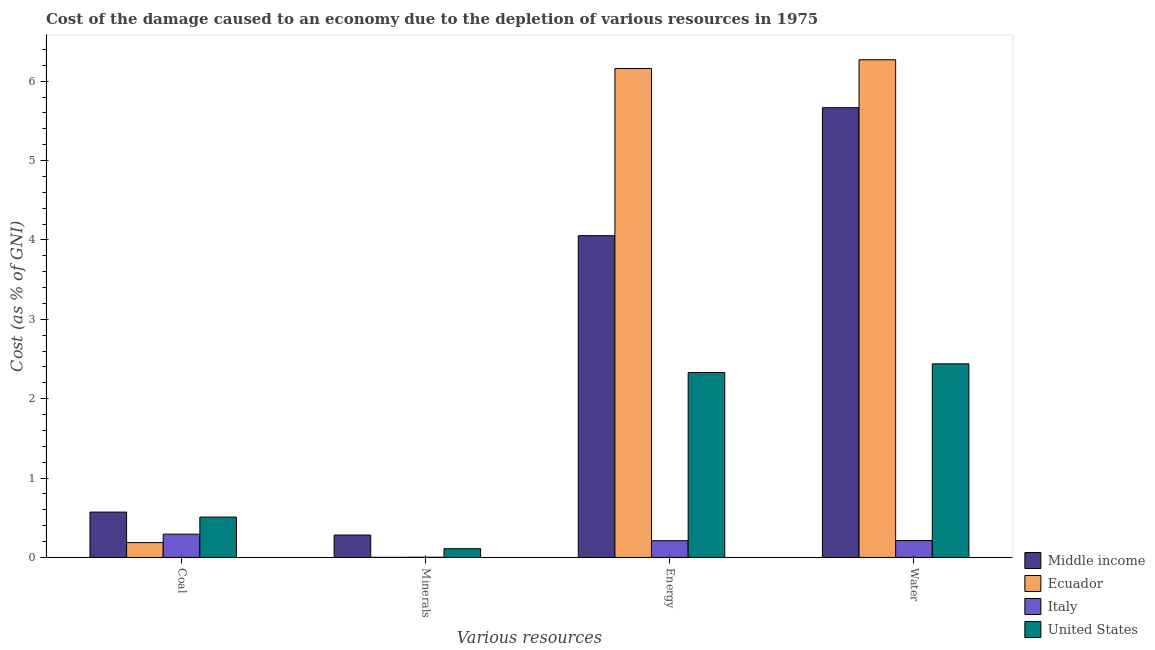How many different coloured bars are there?
Offer a terse response. 4. Are the number of bars on each tick of the X-axis equal?
Give a very brief answer. Yes. How many bars are there on the 1st tick from the left?
Provide a succinct answer. 4. How many bars are there on the 4th tick from the right?
Provide a short and direct response. 4. What is the label of the 4th group of bars from the left?
Your answer should be very brief. Water. What is the cost of damage due to depletion of coal in Ecuador?
Provide a short and direct response. 0.19. Across all countries, what is the maximum cost of damage due to depletion of water?
Your answer should be very brief. 6.27. Across all countries, what is the minimum cost of damage due to depletion of energy?
Your answer should be compact. 0.21. In which country was the cost of damage due to depletion of coal maximum?
Give a very brief answer. Middle income. In which country was the cost of damage due to depletion of coal minimum?
Your answer should be compact. Ecuador. What is the total cost of damage due to depletion of coal in the graph?
Make the answer very short. 1.56. What is the difference between the cost of damage due to depletion of minerals in Ecuador and that in United States?
Make the answer very short. -0.11. What is the difference between the cost of damage due to depletion of energy in Italy and the cost of damage due to depletion of minerals in United States?
Provide a short and direct response. 0.1. What is the average cost of damage due to depletion of coal per country?
Offer a very short reply. 0.39. What is the difference between the cost of damage due to depletion of energy and cost of damage due to depletion of water in Italy?
Offer a very short reply. -0. In how many countries, is the cost of damage due to depletion of coal greater than 6 %?
Your answer should be very brief. 0. What is the ratio of the cost of damage due to depletion of water in Italy to that in Ecuador?
Give a very brief answer. 0.03. Is the difference between the cost of damage due to depletion of energy in Middle income and Italy greater than the difference between the cost of damage due to depletion of minerals in Middle income and Italy?
Your answer should be compact. Yes. What is the difference between the highest and the second highest cost of damage due to depletion of minerals?
Your answer should be very brief. 0.17. What is the difference between the highest and the lowest cost of damage due to depletion of minerals?
Keep it short and to the point. 0.28. In how many countries, is the cost of damage due to depletion of water greater than the average cost of damage due to depletion of water taken over all countries?
Provide a short and direct response. 2. Is it the case that in every country, the sum of the cost of damage due to depletion of water and cost of damage due to depletion of minerals is greater than the sum of cost of damage due to depletion of coal and cost of damage due to depletion of energy?
Give a very brief answer. No. What does the 2nd bar from the right in Water represents?
Provide a short and direct response. Italy. Is it the case that in every country, the sum of the cost of damage due to depletion of coal and cost of damage due to depletion of minerals is greater than the cost of damage due to depletion of energy?
Your answer should be very brief. No. Are all the bars in the graph horizontal?
Your response must be concise. No. How many countries are there in the graph?
Provide a succinct answer. 4. Are the values on the major ticks of Y-axis written in scientific E-notation?
Provide a short and direct response. No. Does the graph contain grids?
Offer a terse response. No. How many legend labels are there?
Your answer should be very brief. 4. How are the legend labels stacked?
Your answer should be very brief. Vertical. What is the title of the graph?
Provide a succinct answer. Cost of the damage caused to an economy due to the depletion of various resources in 1975 . What is the label or title of the X-axis?
Your response must be concise. Various resources. What is the label or title of the Y-axis?
Provide a short and direct response. Cost (as % of GNI). What is the Cost (as % of GNI) of Middle income in Coal?
Make the answer very short. 0.57. What is the Cost (as % of GNI) in Ecuador in Coal?
Ensure brevity in your answer.  0.19. What is the Cost (as % of GNI) of Italy in Coal?
Make the answer very short. 0.29. What is the Cost (as % of GNI) of United States in Coal?
Offer a terse response. 0.51. What is the Cost (as % of GNI) of Middle income in Minerals?
Offer a terse response. 0.28. What is the Cost (as % of GNI) in Ecuador in Minerals?
Offer a very short reply. 0. What is the Cost (as % of GNI) in Italy in Minerals?
Keep it short and to the point. 0. What is the Cost (as % of GNI) in United States in Minerals?
Your response must be concise. 0.11. What is the Cost (as % of GNI) of Middle income in Energy?
Give a very brief answer. 4.05. What is the Cost (as % of GNI) in Ecuador in Energy?
Make the answer very short. 6.16. What is the Cost (as % of GNI) in Italy in Energy?
Provide a short and direct response. 0.21. What is the Cost (as % of GNI) in United States in Energy?
Offer a terse response. 2.33. What is the Cost (as % of GNI) in Middle income in Water?
Your answer should be very brief. 5.67. What is the Cost (as % of GNI) in Ecuador in Water?
Make the answer very short. 6.27. What is the Cost (as % of GNI) of Italy in Water?
Keep it short and to the point. 0.21. What is the Cost (as % of GNI) of United States in Water?
Your response must be concise. 2.44. Across all Various resources, what is the maximum Cost (as % of GNI) in Middle income?
Offer a very short reply. 5.67. Across all Various resources, what is the maximum Cost (as % of GNI) of Ecuador?
Your answer should be compact. 6.27. Across all Various resources, what is the maximum Cost (as % of GNI) of Italy?
Your answer should be compact. 0.29. Across all Various resources, what is the maximum Cost (as % of GNI) of United States?
Offer a very short reply. 2.44. Across all Various resources, what is the minimum Cost (as % of GNI) in Middle income?
Offer a very short reply. 0.28. Across all Various resources, what is the minimum Cost (as % of GNI) in Ecuador?
Keep it short and to the point. 0. Across all Various resources, what is the minimum Cost (as % of GNI) of Italy?
Provide a succinct answer. 0. Across all Various resources, what is the minimum Cost (as % of GNI) in United States?
Offer a terse response. 0.11. What is the total Cost (as % of GNI) in Middle income in the graph?
Ensure brevity in your answer.  10.57. What is the total Cost (as % of GNI) of Ecuador in the graph?
Give a very brief answer. 12.62. What is the total Cost (as % of GNI) in Italy in the graph?
Provide a succinct answer. 0.72. What is the total Cost (as % of GNI) in United States in the graph?
Ensure brevity in your answer.  5.39. What is the difference between the Cost (as % of GNI) in Middle income in Coal and that in Minerals?
Provide a short and direct response. 0.29. What is the difference between the Cost (as % of GNI) of Ecuador in Coal and that in Minerals?
Offer a terse response. 0.19. What is the difference between the Cost (as % of GNI) of Italy in Coal and that in Minerals?
Keep it short and to the point. 0.29. What is the difference between the Cost (as % of GNI) of United States in Coal and that in Minerals?
Provide a short and direct response. 0.4. What is the difference between the Cost (as % of GNI) in Middle income in Coal and that in Energy?
Your response must be concise. -3.48. What is the difference between the Cost (as % of GNI) in Ecuador in Coal and that in Energy?
Provide a short and direct response. -5.97. What is the difference between the Cost (as % of GNI) of Italy in Coal and that in Energy?
Provide a succinct answer. 0.08. What is the difference between the Cost (as % of GNI) in United States in Coal and that in Energy?
Provide a succinct answer. -1.82. What is the difference between the Cost (as % of GNI) of Middle income in Coal and that in Water?
Offer a terse response. -5.1. What is the difference between the Cost (as % of GNI) of Ecuador in Coal and that in Water?
Keep it short and to the point. -6.08. What is the difference between the Cost (as % of GNI) in Italy in Coal and that in Water?
Your answer should be very brief. 0.08. What is the difference between the Cost (as % of GNI) of United States in Coal and that in Water?
Provide a short and direct response. -1.93. What is the difference between the Cost (as % of GNI) in Middle income in Minerals and that in Energy?
Your response must be concise. -3.77. What is the difference between the Cost (as % of GNI) in Ecuador in Minerals and that in Energy?
Your answer should be compact. -6.16. What is the difference between the Cost (as % of GNI) in Italy in Minerals and that in Energy?
Your response must be concise. -0.21. What is the difference between the Cost (as % of GNI) in United States in Minerals and that in Energy?
Provide a short and direct response. -2.22. What is the difference between the Cost (as % of GNI) in Middle income in Minerals and that in Water?
Give a very brief answer. -5.38. What is the difference between the Cost (as % of GNI) of Ecuador in Minerals and that in Water?
Give a very brief answer. -6.27. What is the difference between the Cost (as % of GNI) in Italy in Minerals and that in Water?
Your response must be concise. -0.21. What is the difference between the Cost (as % of GNI) in United States in Minerals and that in Water?
Give a very brief answer. -2.33. What is the difference between the Cost (as % of GNI) in Middle income in Energy and that in Water?
Offer a very short reply. -1.61. What is the difference between the Cost (as % of GNI) of Ecuador in Energy and that in Water?
Your answer should be compact. -0.11. What is the difference between the Cost (as % of GNI) of Italy in Energy and that in Water?
Give a very brief answer. -0. What is the difference between the Cost (as % of GNI) in United States in Energy and that in Water?
Give a very brief answer. -0.11. What is the difference between the Cost (as % of GNI) in Middle income in Coal and the Cost (as % of GNI) in Ecuador in Minerals?
Ensure brevity in your answer.  0.57. What is the difference between the Cost (as % of GNI) in Middle income in Coal and the Cost (as % of GNI) in Italy in Minerals?
Keep it short and to the point. 0.57. What is the difference between the Cost (as % of GNI) of Middle income in Coal and the Cost (as % of GNI) of United States in Minerals?
Give a very brief answer. 0.46. What is the difference between the Cost (as % of GNI) of Ecuador in Coal and the Cost (as % of GNI) of Italy in Minerals?
Provide a short and direct response. 0.18. What is the difference between the Cost (as % of GNI) of Ecuador in Coal and the Cost (as % of GNI) of United States in Minerals?
Offer a very short reply. 0.08. What is the difference between the Cost (as % of GNI) in Italy in Coal and the Cost (as % of GNI) in United States in Minerals?
Give a very brief answer. 0.18. What is the difference between the Cost (as % of GNI) of Middle income in Coal and the Cost (as % of GNI) of Ecuador in Energy?
Your response must be concise. -5.59. What is the difference between the Cost (as % of GNI) of Middle income in Coal and the Cost (as % of GNI) of Italy in Energy?
Keep it short and to the point. 0.36. What is the difference between the Cost (as % of GNI) in Middle income in Coal and the Cost (as % of GNI) in United States in Energy?
Make the answer very short. -1.76. What is the difference between the Cost (as % of GNI) of Ecuador in Coal and the Cost (as % of GNI) of Italy in Energy?
Provide a short and direct response. -0.02. What is the difference between the Cost (as % of GNI) of Ecuador in Coal and the Cost (as % of GNI) of United States in Energy?
Provide a short and direct response. -2.14. What is the difference between the Cost (as % of GNI) in Italy in Coal and the Cost (as % of GNI) in United States in Energy?
Provide a succinct answer. -2.04. What is the difference between the Cost (as % of GNI) in Middle income in Coal and the Cost (as % of GNI) in Ecuador in Water?
Provide a succinct answer. -5.7. What is the difference between the Cost (as % of GNI) in Middle income in Coal and the Cost (as % of GNI) in Italy in Water?
Offer a terse response. 0.36. What is the difference between the Cost (as % of GNI) of Middle income in Coal and the Cost (as % of GNI) of United States in Water?
Your response must be concise. -1.87. What is the difference between the Cost (as % of GNI) in Ecuador in Coal and the Cost (as % of GNI) in Italy in Water?
Your answer should be very brief. -0.03. What is the difference between the Cost (as % of GNI) of Ecuador in Coal and the Cost (as % of GNI) of United States in Water?
Provide a short and direct response. -2.25. What is the difference between the Cost (as % of GNI) of Italy in Coal and the Cost (as % of GNI) of United States in Water?
Your answer should be very brief. -2.15. What is the difference between the Cost (as % of GNI) of Middle income in Minerals and the Cost (as % of GNI) of Ecuador in Energy?
Offer a terse response. -5.88. What is the difference between the Cost (as % of GNI) in Middle income in Minerals and the Cost (as % of GNI) in Italy in Energy?
Your response must be concise. 0.07. What is the difference between the Cost (as % of GNI) in Middle income in Minerals and the Cost (as % of GNI) in United States in Energy?
Offer a terse response. -2.05. What is the difference between the Cost (as % of GNI) in Ecuador in Minerals and the Cost (as % of GNI) in Italy in Energy?
Your answer should be very brief. -0.21. What is the difference between the Cost (as % of GNI) of Ecuador in Minerals and the Cost (as % of GNI) of United States in Energy?
Offer a terse response. -2.33. What is the difference between the Cost (as % of GNI) in Italy in Minerals and the Cost (as % of GNI) in United States in Energy?
Your answer should be compact. -2.33. What is the difference between the Cost (as % of GNI) of Middle income in Minerals and the Cost (as % of GNI) of Ecuador in Water?
Your answer should be very brief. -5.99. What is the difference between the Cost (as % of GNI) in Middle income in Minerals and the Cost (as % of GNI) in Italy in Water?
Provide a short and direct response. 0.07. What is the difference between the Cost (as % of GNI) in Middle income in Minerals and the Cost (as % of GNI) in United States in Water?
Your answer should be very brief. -2.16. What is the difference between the Cost (as % of GNI) in Ecuador in Minerals and the Cost (as % of GNI) in Italy in Water?
Offer a terse response. -0.21. What is the difference between the Cost (as % of GNI) in Ecuador in Minerals and the Cost (as % of GNI) in United States in Water?
Offer a terse response. -2.44. What is the difference between the Cost (as % of GNI) of Italy in Minerals and the Cost (as % of GNI) of United States in Water?
Your answer should be very brief. -2.44. What is the difference between the Cost (as % of GNI) of Middle income in Energy and the Cost (as % of GNI) of Ecuador in Water?
Provide a succinct answer. -2.22. What is the difference between the Cost (as % of GNI) of Middle income in Energy and the Cost (as % of GNI) of Italy in Water?
Provide a succinct answer. 3.84. What is the difference between the Cost (as % of GNI) in Middle income in Energy and the Cost (as % of GNI) in United States in Water?
Give a very brief answer. 1.61. What is the difference between the Cost (as % of GNI) of Ecuador in Energy and the Cost (as % of GNI) of Italy in Water?
Your answer should be compact. 5.95. What is the difference between the Cost (as % of GNI) in Ecuador in Energy and the Cost (as % of GNI) in United States in Water?
Ensure brevity in your answer.  3.72. What is the difference between the Cost (as % of GNI) in Italy in Energy and the Cost (as % of GNI) in United States in Water?
Provide a short and direct response. -2.23. What is the average Cost (as % of GNI) in Middle income per Various resources?
Provide a short and direct response. 2.64. What is the average Cost (as % of GNI) of Ecuador per Various resources?
Your answer should be compact. 3.15. What is the average Cost (as % of GNI) of Italy per Various resources?
Offer a terse response. 0.18. What is the average Cost (as % of GNI) of United States per Various resources?
Keep it short and to the point. 1.35. What is the difference between the Cost (as % of GNI) of Middle income and Cost (as % of GNI) of Ecuador in Coal?
Ensure brevity in your answer.  0.38. What is the difference between the Cost (as % of GNI) of Middle income and Cost (as % of GNI) of Italy in Coal?
Offer a very short reply. 0.28. What is the difference between the Cost (as % of GNI) of Middle income and Cost (as % of GNI) of United States in Coal?
Keep it short and to the point. 0.06. What is the difference between the Cost (as % of GNI) of Ecuador and Cost (as % of GNI) of Italy in Coal?
Keep it short and to the point. -0.11. What is the difference between the Cost (as % of GNI) in Ecuador and Cost (as % of GNI) in United States in Coal?
Your response must be concise. -0.32. What is the difference between the Cost (as % of GNI) of Italy and Cost (as % of GNI) of United States in Coal?
Offer a terse response. -0.22. What is the difference between the Cost (as % of GNI) of Middle income and Cost (as % of GNI) of Ecuador in Minerals?
Ensure brevity in your answer.  0.28. What is the difference between the Cost (as % of GNI) of Middle income and Cost (as % of GNI) of Italy in Minerals?
Your response must be concise. 0.28. What is the difference between the Cost (as % of GNI) in Middle income and Cost (as % of GNI) in United States in Minerals?
Keep it short and to the point. 0.17. What is the difference between the Cost (as % of GNI) of Ecuador and Cost (as % of GNI) of Italy in Minerals?
Your response must be concise. -0. What is the difference between the Cost (as % of GNI) of Ecuador and Cost (as % of GNI) of United States in Minerals?
Offer a very short reply. -0.11. What is the difference between the Cost (as % of GNI) of Italy and Cost (as % of GNI) of United States in Minerals?
Ensure brevity in your answer.  -0.11. What is the difference between the Cost (as % of GNI) of Middle income and Cost (as % of GNI) of Ecuador in Energy?
Make the answer very short. -2.11. What is the difference between the Cost (as % of GNI) of Middle income and Cost (as % of GNI) of Italy in Energy?
Your response must be concise. 3.84. What is the difference between the Cost (as % of GNI) in Middle income and Cost (as % of GNI) in United States in Energy?
Ensure brevity in your answer.  1.72. What is the difference between the Cost (as % of GNI) in Ecuador and Cost (as % of GNI) in Italy in Energy?
Offer a very short reply. 5.95. What is the difference between the Cost (as % of GNI) in Ecuador and Cost (as % of GNI) in United States in Energy?
Give a very brief answer. 3.83. What is the difference between the Cost (as % of GNI) in Italy and Cost (as % of GNI) in United States in Energy?
Provide a short and direct response. -2.12. What is the difference between the Cost (as % of GNI) in Middle income and Cost (as % of GNI) in Ecuador in Water?
Give a very brief answer. -0.6. What is the difference between the Cost (as % of GNI) of Middle income and Cost (as % of GNI) of Italy in Water?
Keep it short and to the point. 5.45. What is the difference between the Cost (as % of GNI) of Middle income and Cost (as % of GNI) of United States in Water?
Your answer should be very brief. 3.23. What is the difference between the Cost (as % of GNI) in Ecuador and Cost (as % of GNI) in Italy in Water?
Provide a short and direct response. 6.06. What is the difference between the Cost (as % of GNI) of Ecuador and Cost (as % of GNI) of United States in Water?
Provide a short and direct response. 3.83. What is the difference between the Cost (as % of GNI) in Italy and Cost (as % of GNI) in United States in Water?
Give a very brief answer. -2.23. What is the ratio of the Cost (as % of GNI) of Middle income in Coal to that in Minerals?
Make the answer very short. 2.03. What is the ratio of the Cost (as % of GNI) of Ecuador in Coal to that in Minerals?
Give a very brief answer. 352.48. What is the ratio of the Cost (as % of GNI) of Italy in Coal to that in Minerals?
Offer a terse response. 136.52. What is the ratio of the Cost (as % of GNI) of United States in Coal to that in Minerals?
Your answer should be very brief. 4.63. What is the ratio of the Cost (as % of GNI) in Middle income in Coal to that in Energy?
Keep it short and to the point. 0.14. What is the ratio of the Cost (as % of GNI) of Ecuador in Coal to that in Energy?
Make the answer very short. 0.03. What is the ratio of the Cost (as % of GNI) in Italy in Coal to that in Energy?
Provide a succinct answer. 1.39. What is the ratio of the Cost (as % of GNI) of United States in Coal to that in Energy?
Your answer should be compact. 0.22. What is the ratio of the Cost (as % of GNI) of Middle income in Coal to that in Water?
Ensure brevity in your answer.  0.1. What is the ratio of the Cost (as % of GNI) of Ecuador in Coal to that in Water?
Keep it short and to the point. 0.03. What is the ratio of the Cost (as % of GNI) of Italy in Coal to that in Water?
Your answer should be very brief. 1.38. What is the ratio of the Cost (as % of GNI) of United States in Coal to that in Water?
Keep it short and to the point. 0.21. What is the ratio of the Cost (as % of GNI) in Middle income in Minerals to that in Energy?
Keep it short and to the point. 0.07. What is the ratio of the Cost (as % of GNI) in Ecuador in Minerals to that in Energy?
Your response must be concise. 0. What is the ratio of the Cost (as % of GNI) in Italy in Minerals to that in Energy?
Give a very brief answer. 0.01. What is the ratio of the Cost (as % of GNI) in United States in Minerals to that in Energy?
Offer a terse response. 0.05. What is the ratio of the Cost (as % of GNI) in Middle income in Minerals to that in Water?
Make the answer very short. 0.05. What is the ratio of the Cost (as % of GNI) of Italy in Minerals to that in Water?
Your answer should be very brief. 0.01. What is the ratio of the Cost (as % of GNI) in United States in Minerals to that in Water?
Your answer should be compact. 0.04. What is the ratio of the Cost (as % of GNI) in Middle income in Energy to that in Water?
Give a very brief answer. 0.72. What is the ratio of the Cost (as % of GNI) of Ecuador in Energy to that in Water?
Offer a very short reply. 0.98. What is the ratio of the Cost (as % of GNI) in United States in Energy to that in Water?
Make the answer very short. 0.95. What is the difference between the highest and the second highest Cost (as % of GNI) in Middle income?
Your answer should be compact. 1.61. What is the difference between the highest and the second highest Cost (as % of GNI) of Ecuador?
Your response must be concise. 0.11. What is the difference between the highest and the second highest Cost (as % of GNI) in Italy?
Your answer should be compact. 0.08. What is the difference between the highest and the second highest Cost (as % of GNI) of United States?
Your answer should be very brief. 0.11. What is the difference between the highest and the lowest Cost (as % of GNI) of Middle income?
Keep it short and to the point. 5.38. What is the difference between the highest and the lowest Cost (as % of GNI) of Ecuador?
Give a very brief answer. 6.27. What is the difference between the highest and the lowest Cost (as % of GNI) of Italy?
Offer a terse response. 0.29. What is the difference between the highest and the lowest Cost (as % of GNI) of United States?
Offer a terse response. 2.33. 